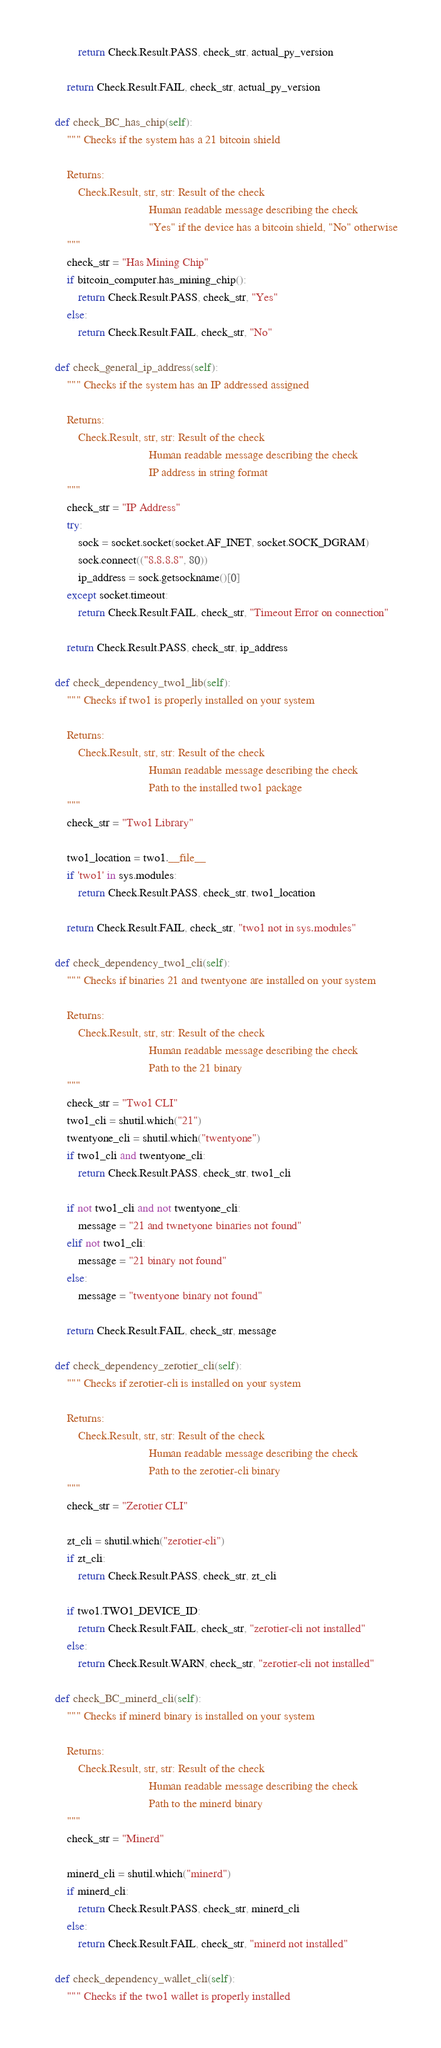Convert code to text. <code><loc_0><loc_0><loc_500><loc_500><_Python_>            return Check.Result.PASS, check_str, actual_py_version

        return Check.Result.FAIL, check_str, actual_py_version

    def check_BC_has_chip(self):
        """ Checks if the system has a 21 bitcoin shield

        Returns:
            Check.Result, str, str: Result of the check
                                    Human readable message describing the check
                                    "Yes" if the device has a bitcoin shield, "No" otherwise
        """
        check_str = "Has Mining Chip"
        if bitcoin_computer.has_mining_chip():
            return Check.Result.PASS, check_str, "Yes"
        else:
            return Check.Result.FAIL, check_str, "No"

    def check_general_ip_address(self):
        """ Checks if the system has an IP addressed assigned

        Returns:
            Check.Result, str, str: Result of the check
                                    Human readable message describing the check
                                    IP address in string format
        """
        check_str = "IP Address"
        try:
            sock = socket.socket(socket.AF_INET, socket.SOCK_DGRAM)
            sock.connect(("8.8.8.8", 80))
            ip_address = sock.getsockname()[0]
        except socket.timeout:
            return Check.Result.FAIL, check_str, "Timeout Error on connection"

        return Check.Result.PASS, check_str, ip_address

    def check_dependency_two1_lib(self):
        """ Checks if two1 is properly installed on your system

        Returns:
            Check.Result, str, str: Result of the check
                                    Human readable message describing the check
                                    Path to the installed two1 package
        """
        check_str = "Two1 Library"

        two1_location = two1.__file__
        if 'two1' in sys.modules:
            return Check.Result.PASS, check_str, two1_location

        return Check.Result.FAIL, check_str, "two1 not in sys.modules"

    def check_dependency_two1_cli(self):
        """ Checks if binaries 21 and twentyone are installed on your system

        Returns:
            Check.Result, str, str: Result of the check
                                    Human readable message describing the check
                                    Path to the 21 binary
        """
        check_str = "Two1 CLI"
        two1_cli = shutil.which("21")
        twentyone_cli = shutil.which("twentyone")
        if two1_cli and twentyone_cli:
            return Check.Result.PASS, check_str, two1_cli

        if not two1_cli and not twentyone_cli:
            message = "21 and twnetyone binaries not found"
        elif not two1_cli:
            message = "21 binary not found"
        else:
            message = "twentyone binary not found"

        return Check.Result.FAIL, check_str, message

    def check_dependency_zerotier_cli(self):
        """ Checks if zerotier-cli is installed on your system

        Returns:
            Check.Result, str, str: Result of the check
                                    Human readable message describing the check
                                    Path to the zerotier-cli binary
        """
        check_str = "Zerotier CLI"

        zt_cli = shutil.which("zerotier-cli")
        if zt_cli:
            return Check.Result.PASS, check_str, zt_cli

        if two1.TWO1_DEVICE_ID:
            return Check.Result.FAIL, check_str, "zerotier-cli not installed"
        else:
            return Check.Result.WARN, check_str, "zerotier-cli not installed"

    def check_BC_minerd_cli(self):
        """ Checks if minerd binary is installed on your system

        Returns:
            Check.Result, str, str: Result of the check
                                    Human readable message describing the check
                                    Path to the minerd binary
        """
        check_str = "Minerd"

        minerd_cli = shutil.which("minerd")
        if minerd_cli:
            return Check.Result.PASS, check_str, minerd_cli
        else:
            return Check.Result.FAIL, check_str, "minerd not installed"

    def check_dependency_wallet_cli(self):
        """ Checks if the two1 wallet is properly installed
</code> 